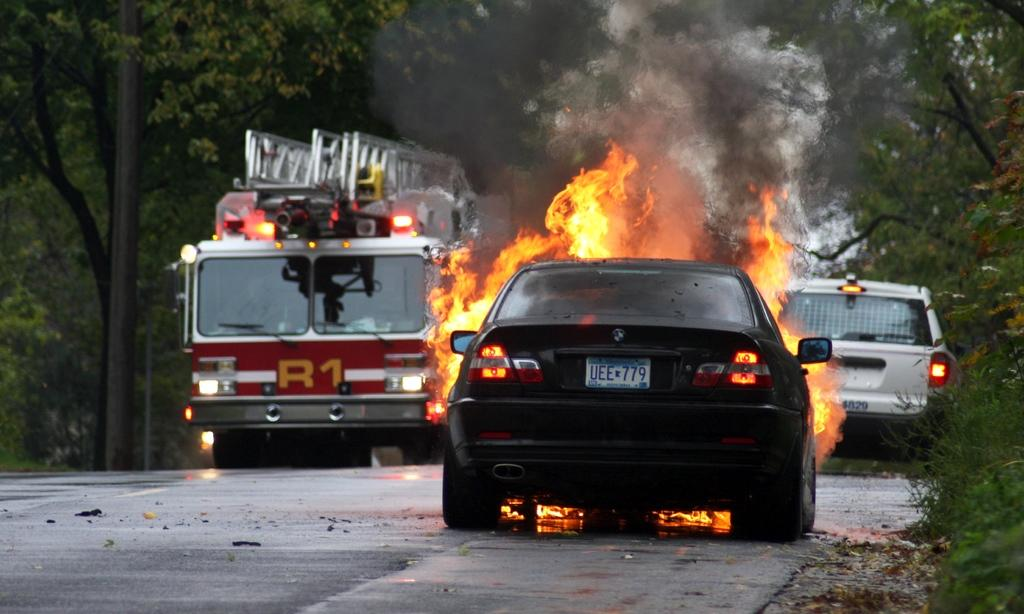What is happening to the car in the image? There is a car on fire in the image. What else can be seen on the road in the image? There are other vehicles on the road in the image. What type of vegetation is present on both sides of the road? There are green trees on both sides of the road in the image. How is the fire depicted in the image? The fire is depicted in orange and yellow colors. What type of marble can be seen on the slope in the image? There is no marble or slope present in the image. The image shows a car on fire and other vehicles on the road, with green trees on both sides. 